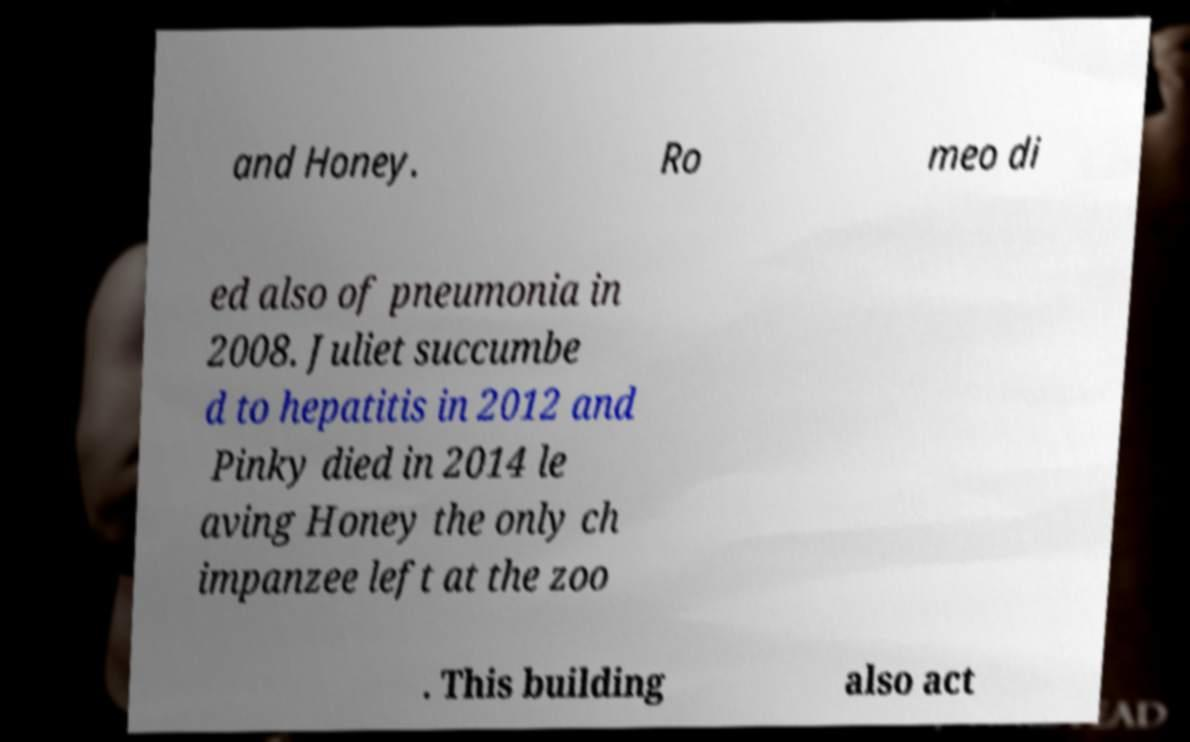What messages or text are displayed in this image? I need them in a readable, typed format. and Honey. Ro meo di ed also of pneumonia in 2008. Juliet succumbe d to hepatitis in 2012 and Pinky died in 2014 le aving Honey the only ch impanzee left at the zoo . This building also act 